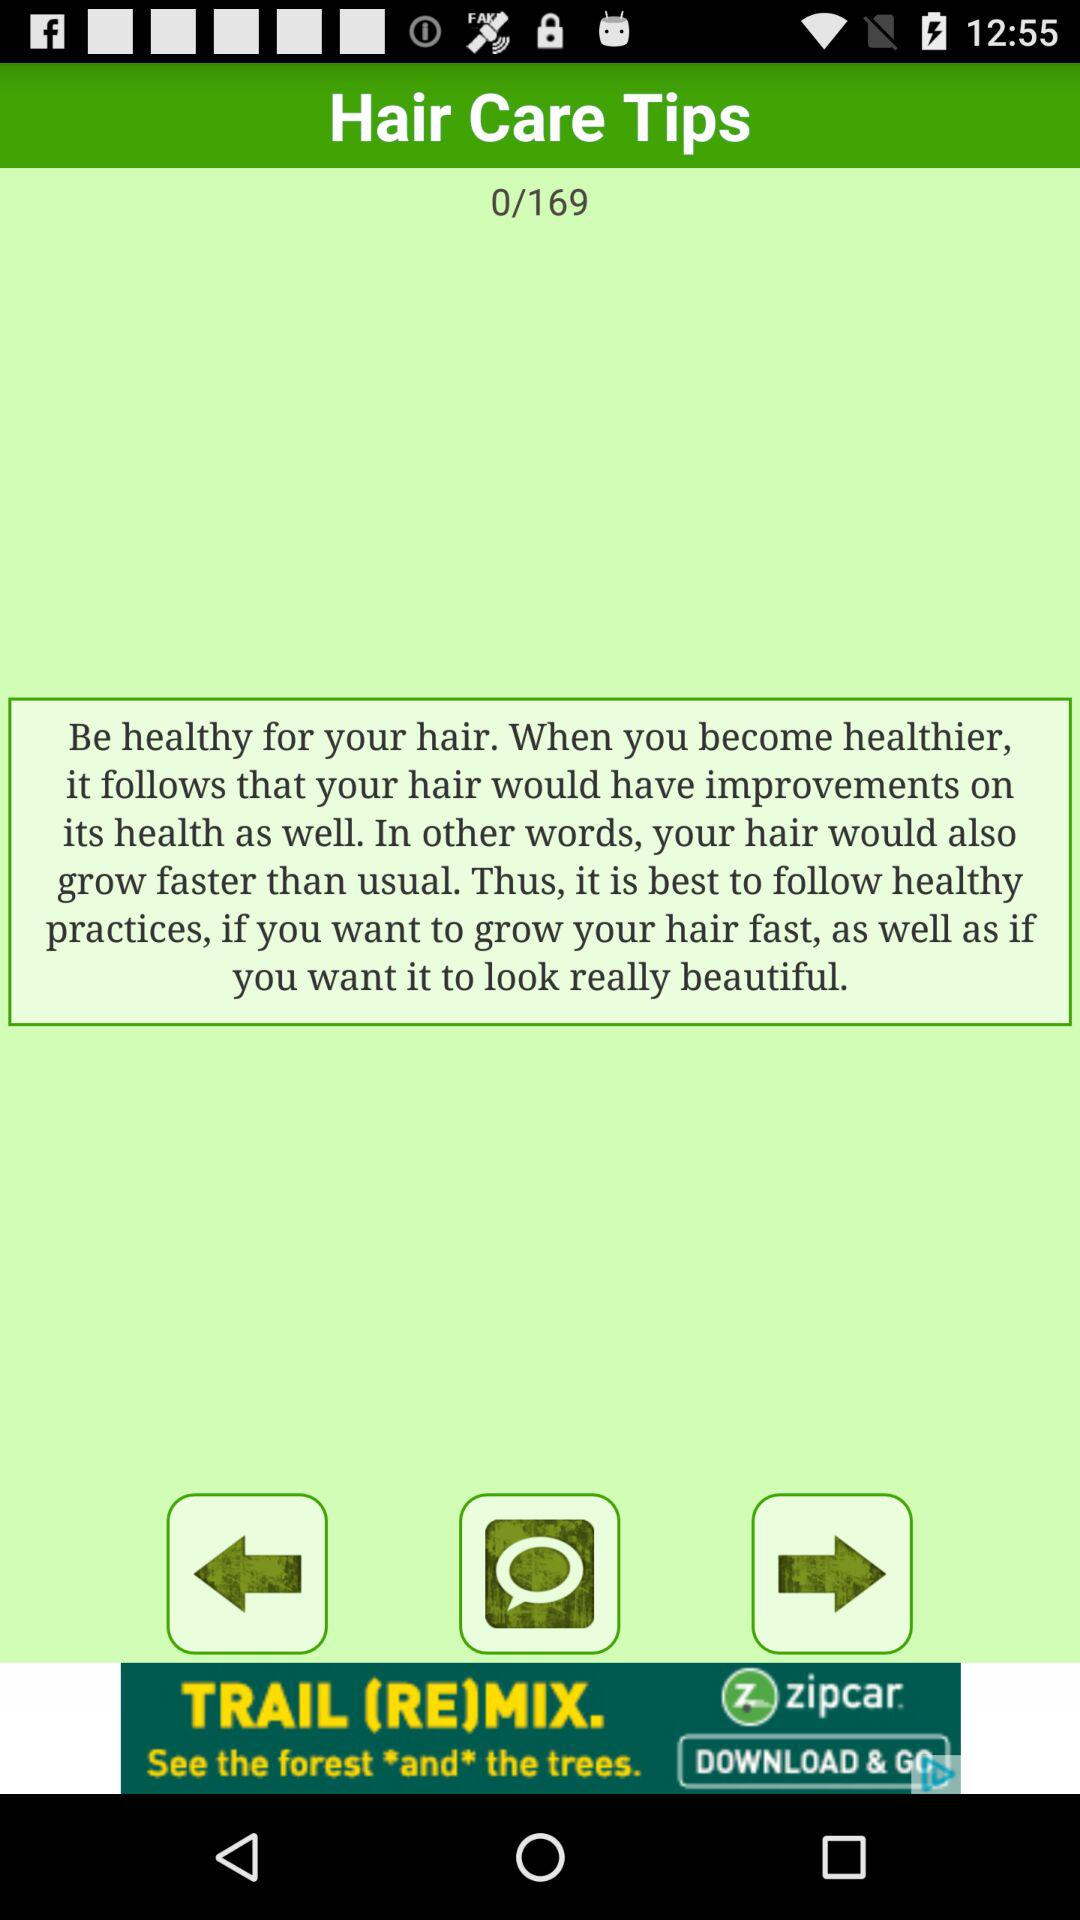What does slide #1 show?
When the provided information is insufficient, respond with <no answer>. <no answer> 